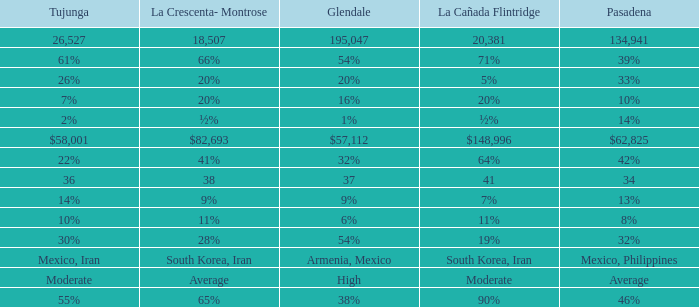What is the figure for La Canada Flintridge when Pasadena is 34? 41.0. 